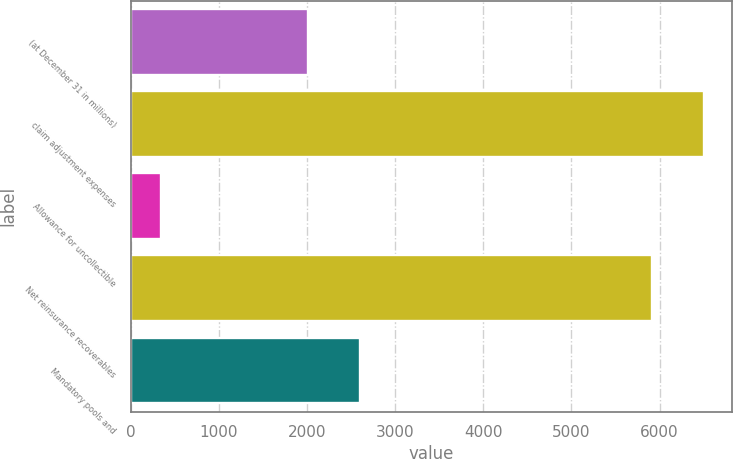Convert chart. <chart><loc_0><loc_0><loc_500><loc_500><bar_chart><fcel>(at December 31 in millions)<fcel>claim adjustment expenses<fcel>Allowance for uncollectible<fcel>Net reinsurance recoverables<fcel>Mandatory pools and<nl><fcel>2011<fcel>6501<fcel>345<fcel>5910<fcel>2602<nl></chart> 